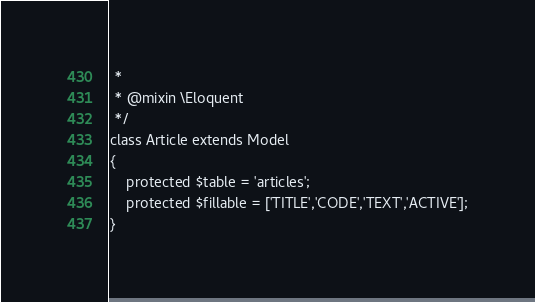<code> <loc_0><loc_0><loc_500><loc_500><_PHP_> *
 * @mixin \Eloquent
 */
class Article extends Model
{
    protected $table = 'articles';
	protected $fillable = ['TITLE','CODE','TEXT','ACTIVE'];
}
</code> 